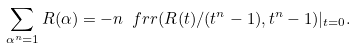<formula> <loc_0><loc_0><loc_500><loc_500>\sum _ { \alpha ^ { n } = 1 } R ( \alpha ) = - n \ f r r ( R ( t ) / ( t ^ { n } - 1 ) , t ^ { n } - 1 ) | _ { t = 0 } .</formula> 